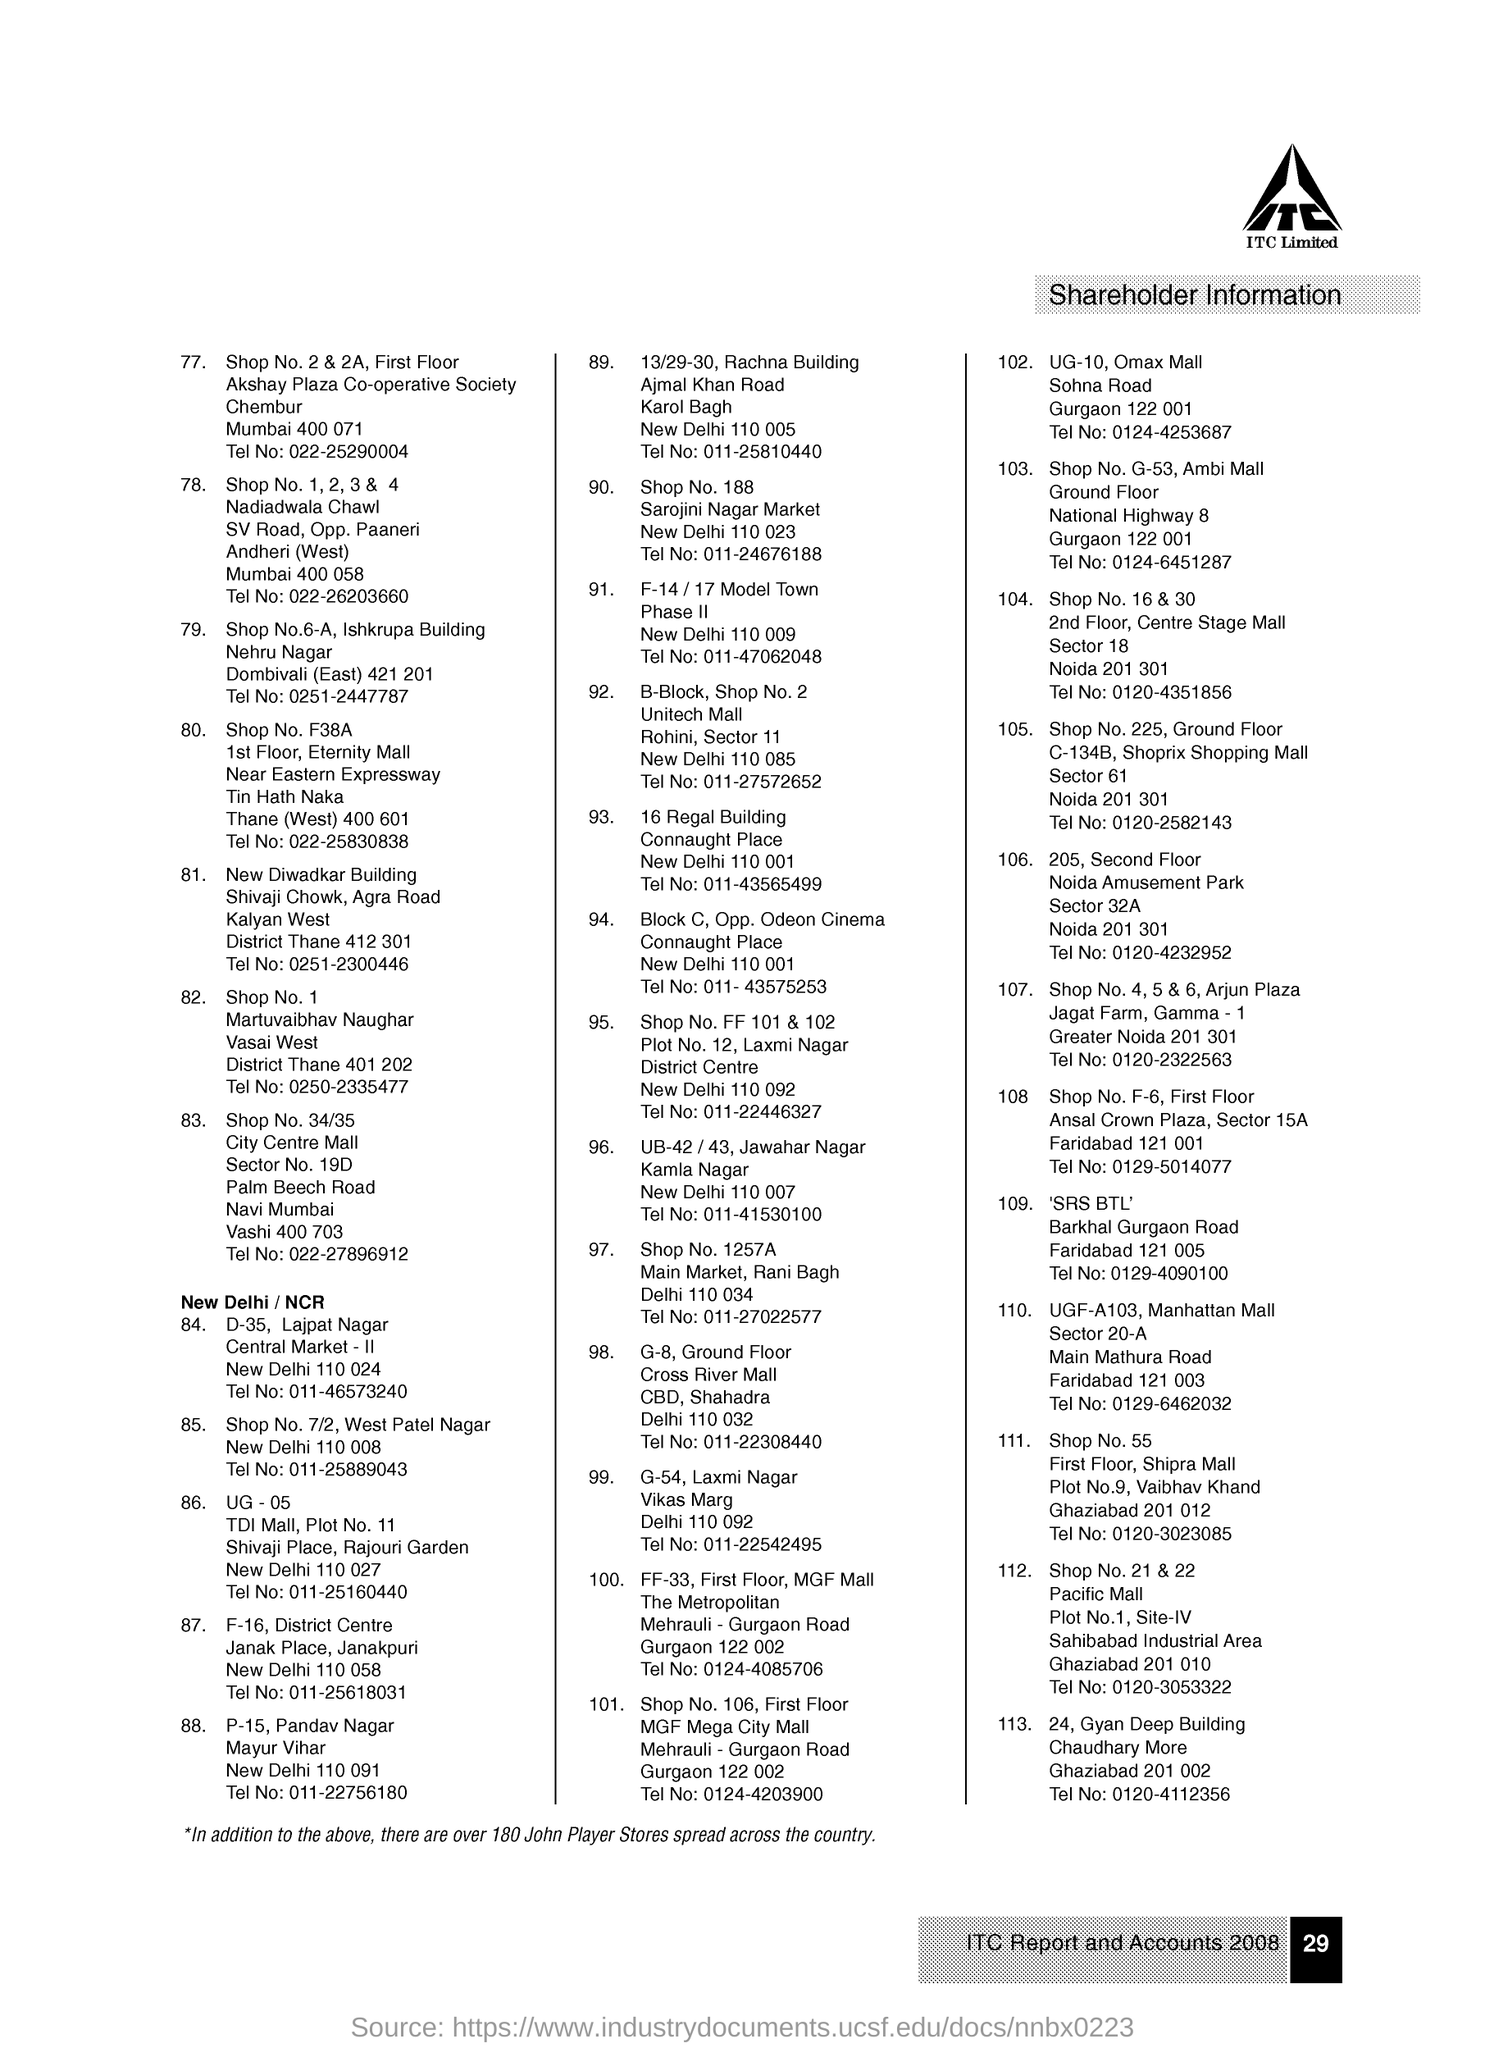Highlight a few significant elements in this photo. ITC Limited is mentioned. The document pertains to shareholder information. The information provided is that the page number on the document is 29. 